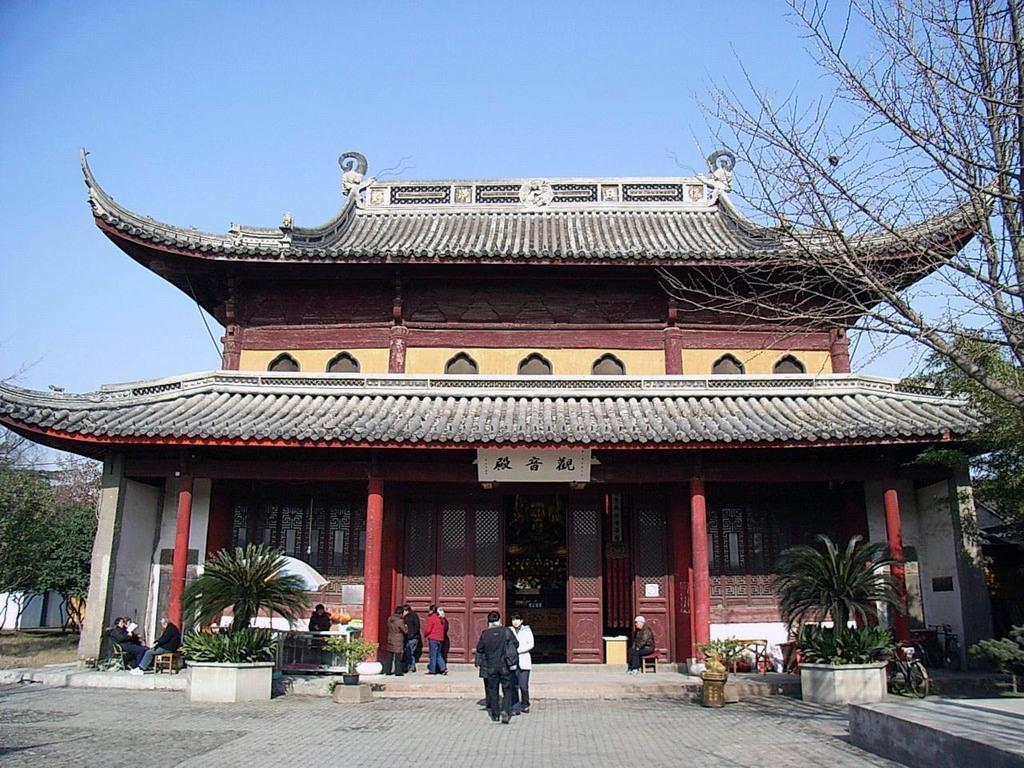Describe this image in one or two sentences. In this picture there is a yellow and red color Chinese roof tile house. In the front we can see a group of women standing and discussing something. On both the side there is a small tree plant. On the right side of the image there is a huge dry tree. 